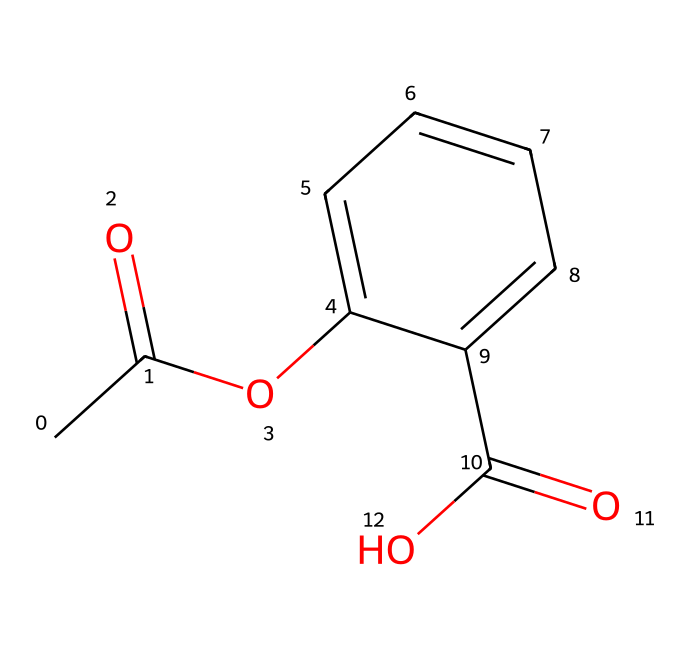What is the molecular formula of aspirin? To determine the molecular formula from the SMILES representation, we need to identify the specific atoms present. In this case, the SMILES indicates 9 carbon atoms (C), 8 hydrogen atoms (H), and 4 oxygen atoms (O). Combining these counts, the molecular formula is C9H8O4.
Answer: C9H8O4 How many carbon atoms are present in aspirin? By analyzing the SMILES, each "C" represents a carbon atom. There are a total of 9 instances of "C" indicating that there are 9 carbon atoms in the structure.
Answer: 9 What type of functional groups are present in aspirin? In the provided SMILES, we can identify an ester group (due to the presence of -OC(=O)-) and a carboxylic acid group (due to the presence of -C(=O)O). Hence, aspirin contains both an ester and a carboxylic acid functional group.
Answer: ester and carboxylic acid What is the total number of double bonds in the aspirin structure? By examining the SMILES, we can locate the double bonds represented by "=" signs. There are 2 double bonds in the molecule: one in the ester group and one in the carboxylic acid group. Therefore, the total number of double bonds is 2.
Answer: 2 How does the structure of aspirin relate to its anti-inflammatory properties? Aspirin contains a carboxylic acid group, which contributes to its ability to inhibit cyclooxygenase (COX) enzymes, thus reducing inflammation. The presence of the acetyl group increases its specificity to inhibit COX-1, leading to its anti-inflammatory effects.
Answer: carboxylic acid group What is the total number of rings in the aspirin structure? By evaluating the cyclic element in the SMILES, we observe that there is one ring present, which can be identified from the "C1" notation. Thus, aspirin contains a single cyclic (aromatic) structure.
Answer: 1 